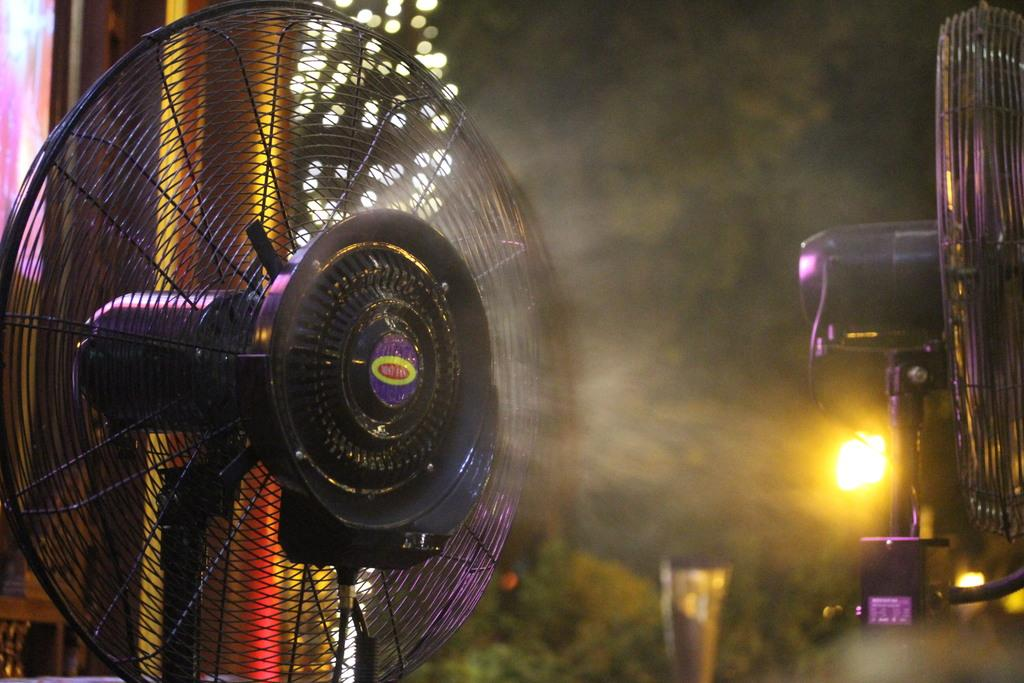What type of cooling device is present in the image? There are table fans in the image. What other objects can be seen in the image? There are plants and lights visible in the image. What is the color of the background in the image? The background of the image is black. What type of jelly is being used to decorate the plants in the image? There is no jelly present in the image; it features table fans, plants, and lights with a black background. How many houses are visible in the image? There are no houses visible in the image. 